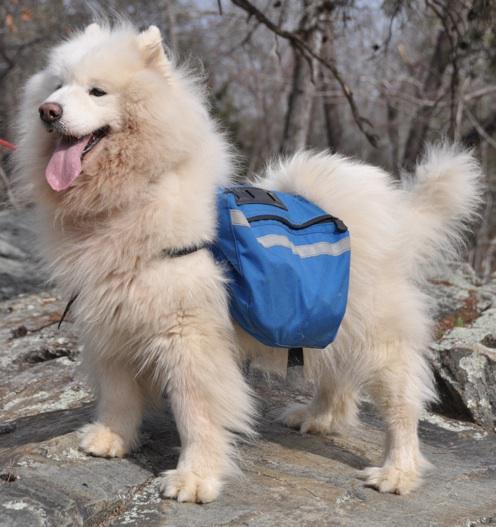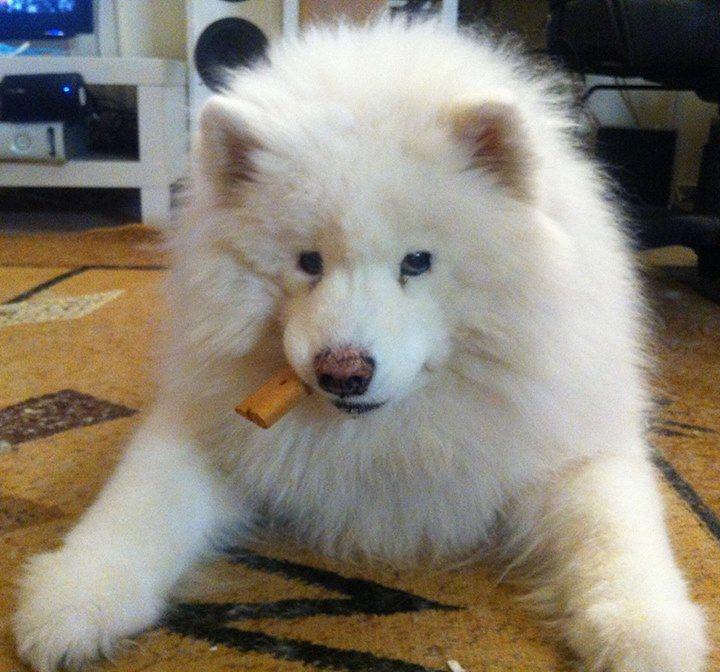The first image is the image on the left, the second image is the image on the right. For the images shown, is this caption "One dog is outdoors, and one dog is indoors." true? Answer yes or no. Yes. The first image is the image on the left, the second image is the image on the right. Evaluate the accuracy of this statement regarding the images: "An image shows one white dog wearing something other than a dog collar.". Is it true? Answer yes or no. Yes. 